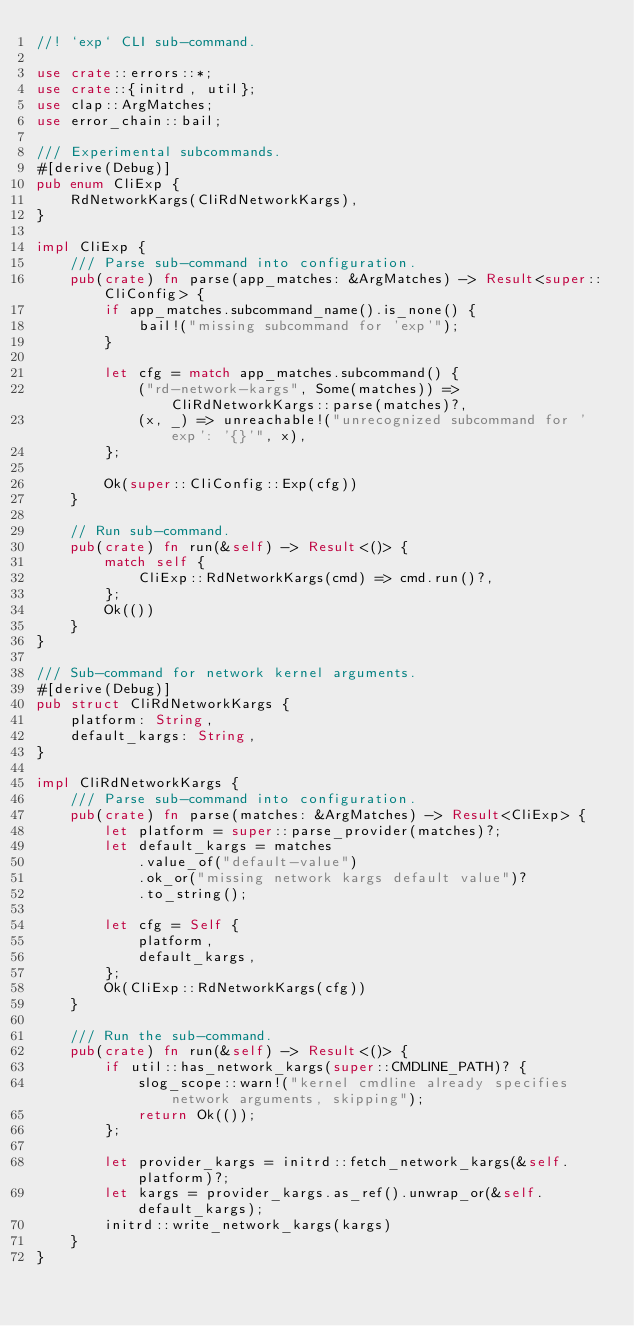Convert code to text. <code><loc_0><loc_0><loc_500><loc_500><_Rust_>//! `exp` CLI sub-command.

use crate::errors::*;
use crate::{initrd, util};
use clap::ArgMatches;
use error_chain::bail;

/// Experimental subcommands.
#[derive(Debug)]
pub enum CliExp {
    RdNetworkKargs(CliRdNetworkKargs),
}

impl CliExp {
    /// Parse sub-command into configuration.
    pub(crate) fn parse(app_matches: &ArgMatches) -> Result<super::CliConfig> {
        if app_matches.subcommand_name().is_none() {
            bail!("missing subcommand for 'exp'");
        }

        let cfg = match app_matches.subcommand() {
            ("rd-network-kargs", Some(matches)) => CliRdNetworkKargs::parse(matches)?,
            (x, _) => unreachable!("unrecognized subcommand for 'exp': '{}'", x),
        };

        Ok(super::CliConfig::Exp(cfg))
    }

    // Run sub-command.
    pub(crate) fn run(&self) -> Result<()> {
        match self {
            CliExp::RdNetworkKargs(cmd) => cmd.run()?,
        };
        Ok(())
    }
}

/// Sub-command for network kernel arguments.
#[derive(Debug)]
pub struct CliRdNetworkKargs {
    platform: String,
    default_kargs: String,
}

impl CliRdNetworkKargs {
    /// Parse sub-command into configuration.
    pub(crate) fn parse(matches: &ArgMatches) -> Result<CliExp> {
        let platform = super::parse_provider(matches)?;
        let default_kargs = matches
            .value_of("default-value")
            .ok_or("missing network kargs default value")?
            .to_string();

        let cfg = Self {
            platform,
            default_kargs,
        };
        Ok(CliExp::RdNetworkKargs(cfg))
    }

    /// Run the sub-command.
    pub(crate) fn run(&self) -> Result<()> {
        if util::has_network_kargs(super::CMDLINE_PATH)? {
            slog_scope::warn!("kernel cmdline already specifies network arguments, skipping");
            return Ok(());
        };

        let provider_kargs = initrd::fetch_network_kargs(&self.platform)?;
        let kargs = provider_kargs.as_ref().unwrap_or(&self.default_kargs);
        initrd::write_network_kargs(kargs)
    }
}
</code> 